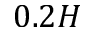<formula> <loc_0><loc_0><loc_500><loc_500>0 . 2 H</formula> 